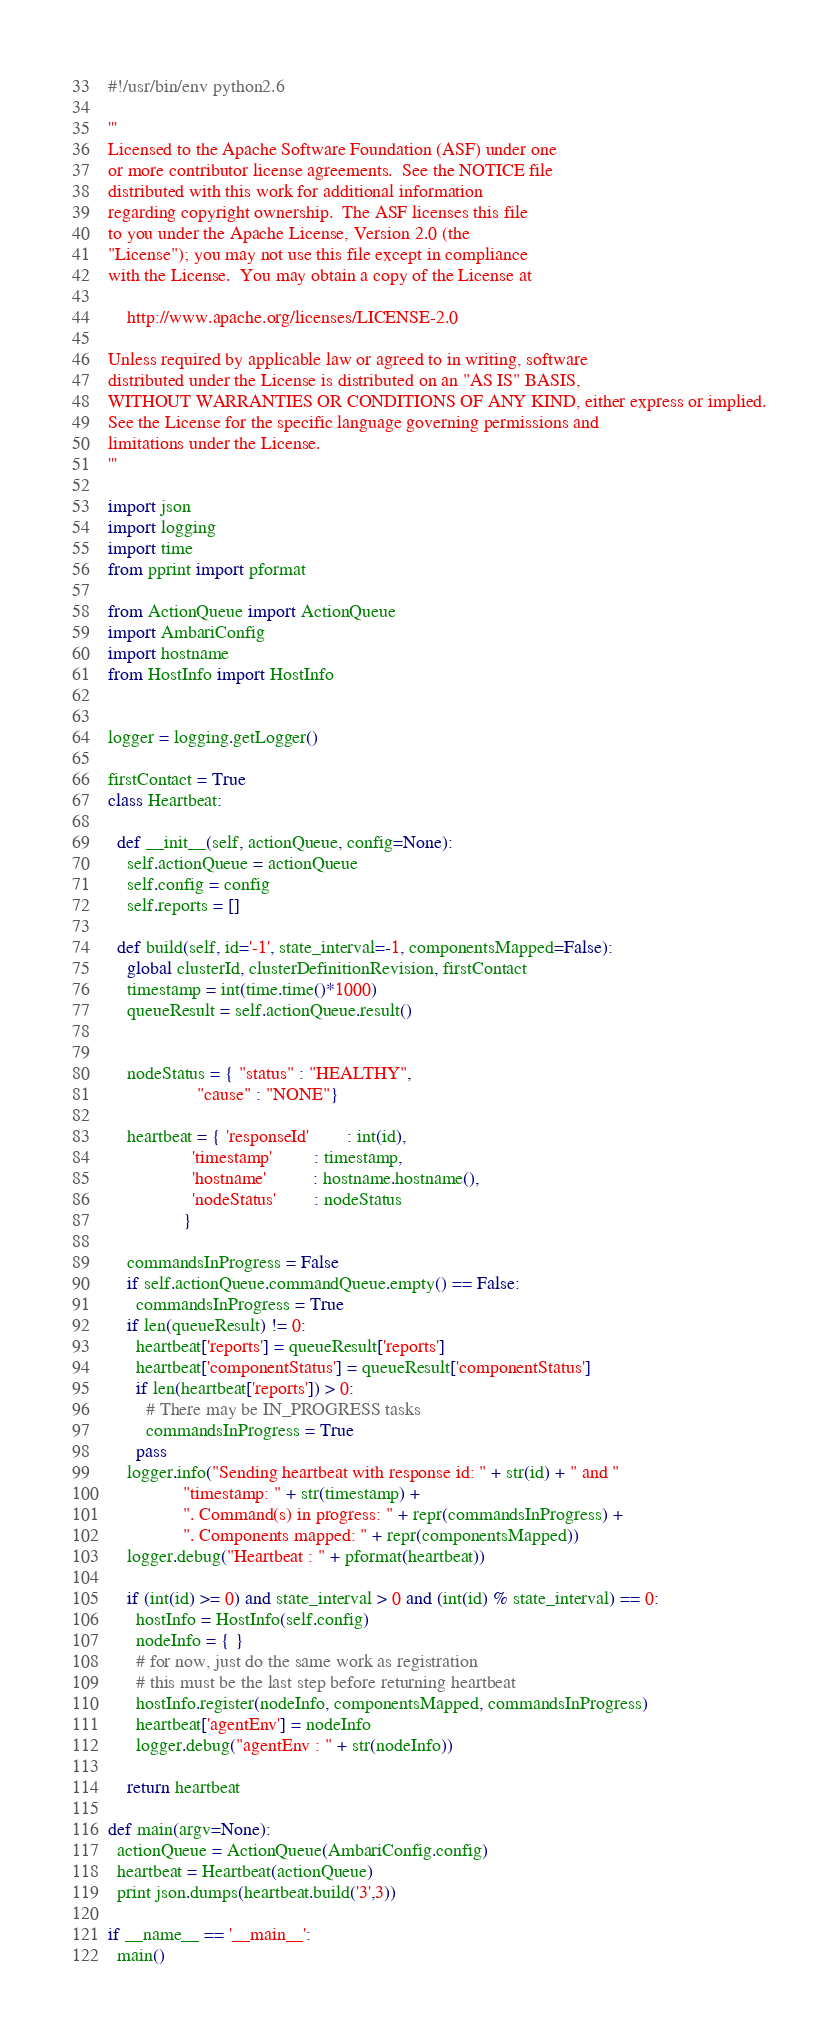Convert code to text. <code><loc_0><loc_0><loc_500><loc_500><_Python_>#!/usr/bin/env python2.6

'''
Licensed to the Apache Software Foundation (ASF) under one
or more contributor license agreements.  See the NOTICE file
distributed with this work for additional information
regarding copyright ownership.  The ASF licenses this file
to you under the Apache License, Version 2.0 (the
"License"); you may not use this file except in compliance
with the License.  You may obtain a copy of the License at

    http://www.apache.org/licenses/LICENSE-2.0

Unless required by applicable law or agreed to in writing, software
distributed under the License is distributed on an "AS IS" BASIS,
WITHOUT WARRANTIES OR CONDITIONS OF ANY KIND, either express or implied.
See the License for the specific language governing permissions and
limitations under the License.
'''

import json
import logging
import time
from pprint import pformat

from ActionQueue import ActionQueue
import AmbariConfig
import hostname
from HostInfo import HostInfo


logger = logging.getLogger()

firstContact = True
class Heartbeat:

  def __init__(self, actionQueue, config=None):
    self.actionQueue = actionQueue
    self.config = config
    self.reports = []

  def build(self, id='-1', state_interval=-1, componentsMapped=False):
    global clusterId, clusterDefinitionRevision, firstContact
    timestamp = int(time.time()*1000)
    queueResult = self.actionQueue.result()

    
    nodeStatus = { "status" : "HEALTHY",
                   "cause" : "NONE"}
    
    heartbeat = { 'responseId'        : int(id),
                  'timestamp'         : timestamp,
                  'hostname'          : hostname.hostname(),
                  'nodeStatus'        : nodeStatus
                }

    commandsInProgress = False
    if self.actionQueue.commandQueue.empty() == False:
      commandsInProgress = True
    if len(queueResult) != 0:
      heartbeat['reports'] = queueResult['reports']
      heartbeat['componentStatus'] = queueResult['componentStatus']
      if len(heartbeat['reports']) > 0:
        # There may be IN_PROGRESS tasks
        commandsInProgress = True
      pass
    logger.info("Sending heartbeat with response id: " + str(id) + " and "
                "timestamp: " + str(timestamp) +
                ". Command(s) in progress: " + repr(commandsInProgress) +
                ". Components mapped: " + repr(componentsMapped))
    logger.debug("Heartbeat : " + pformat(heartbeat))

    if (int(id) >= 0) and state_interval > 0 and (int(id) % state_interval) == 0:
      hostInfo = HostInfo(self.config)
      nodeInfo = { }
      # for now, just do the same work as registration
      # this must be the last step before returning heartbeat
      hostInfo.register(nodeInfo, componentsMapped, commandsInProgress)
      heartbeat['agentEnv'] = nodeInfo
      logger.debug("agentEnv : " + str(nodeInfo))

    return heartbeat

def main(argv=None):
  actionQueue = ActionQueue(AmbariConfig.config)
  heartbeat = Heartbeat(actionQueue)
  print json.dumps(heartbeat.build('3',3))

if __name__ == '__main__':
  main()
</code> 